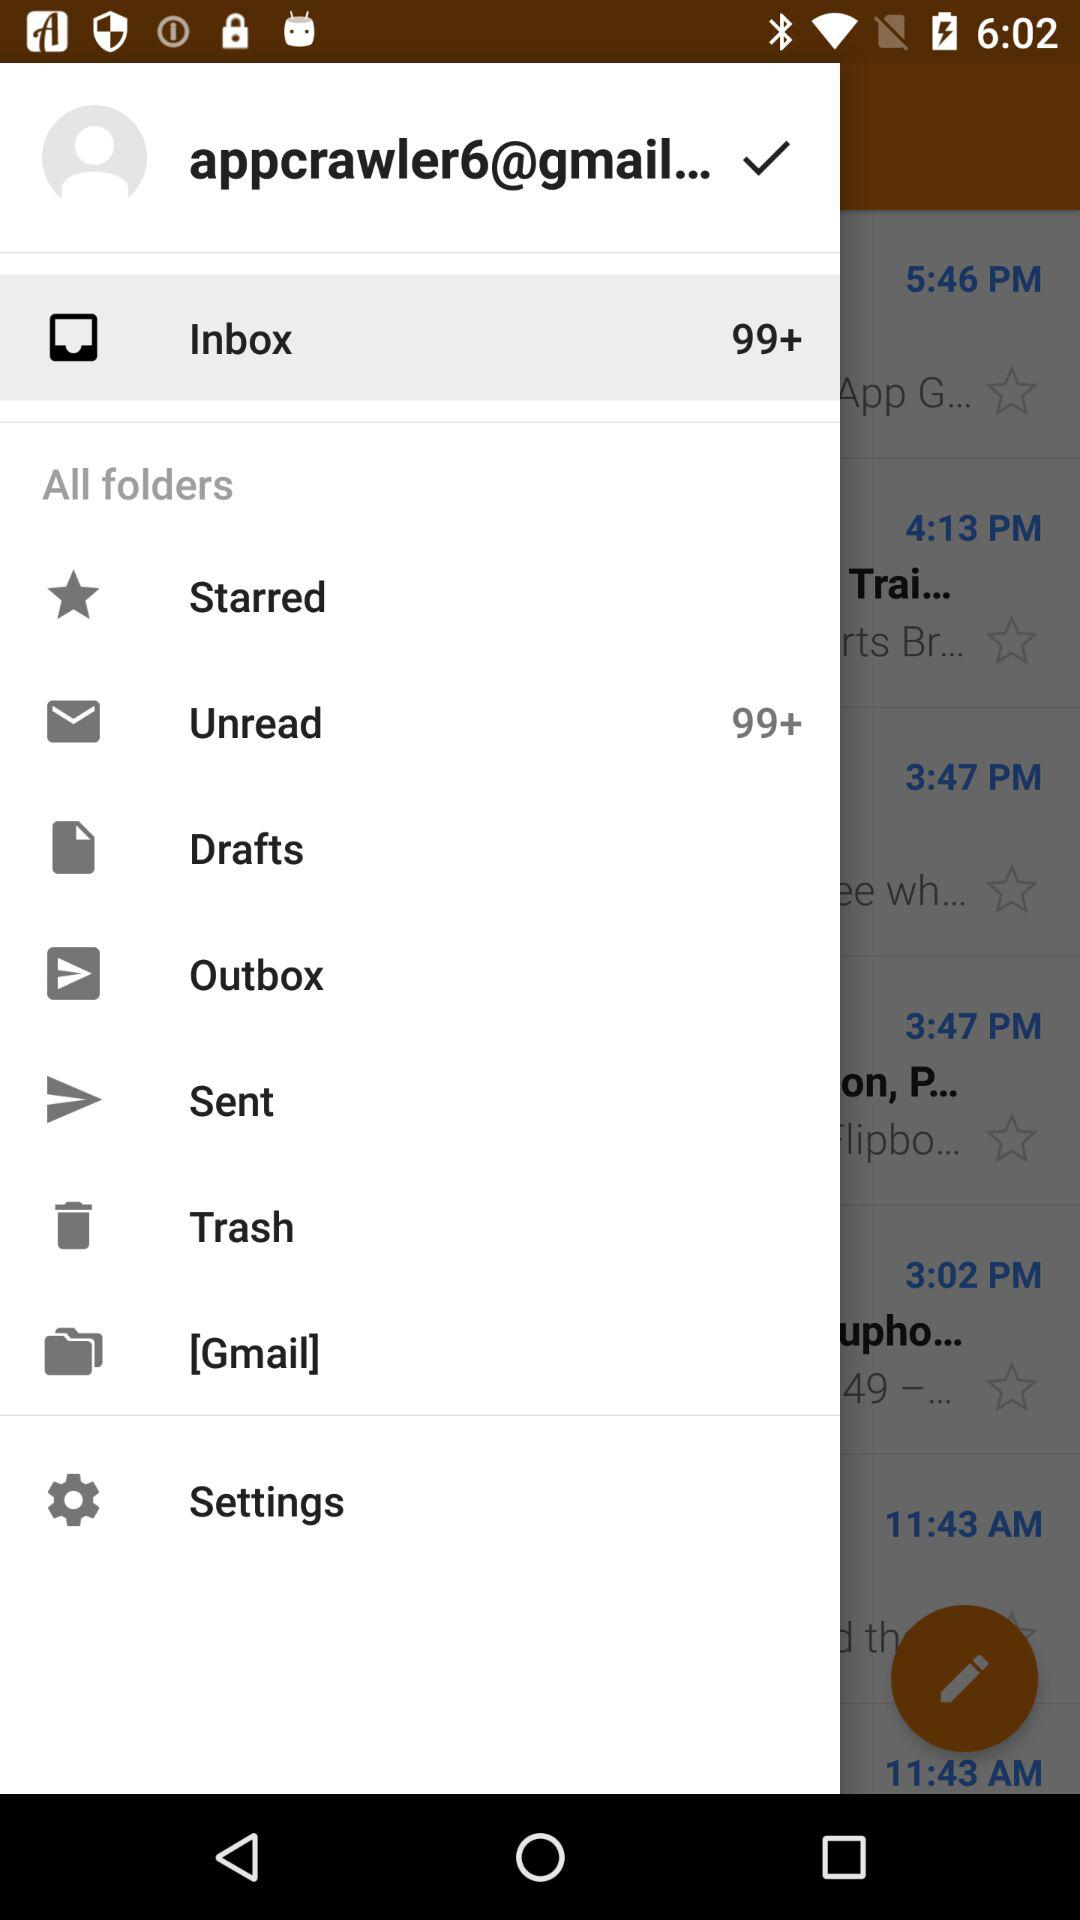How many unread emails are there in the inbox?
Answer the question using a single word or phrase. 99+ 